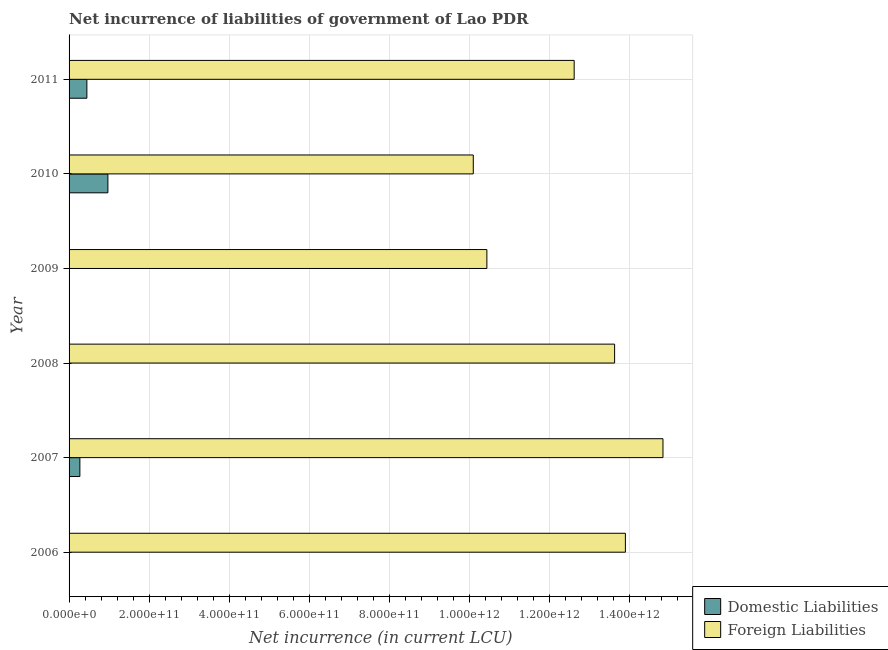How many different coloured bars are there?
Your answer should be very brief. 2. Are the number of bars on each tick of the Y-axis equal?
Provide a succinct answer. No. What is the label of the 2nd group of bars from the top?
Ensure brevity in your answer.  2010. In how many cases, is the number of bars for a given year not equal to the number of legend labels?
Make the answer very short. 3. What is the net incurrence of foreign liabilities in 2008?
Make the answer very short. 1.36e+12. Across all years, what is the maximum net incurrence of domestic liabilities?
Your answer should be compact. 9.70e+1. Across all years, what is the minimum net incurrence of foreign liabilities?
Provide a short and direct response. 1.01e+12. In which year was the net incurrence of domestic liabilities maximum?
Provide a short and direct response. 2010. What is the total net incurrence of foreign liabilities in the graph?
Offer a terse response. 7.55e+12. What is the difference between the net incurrence of foreign liabilities in 2008 and that in 2009?
Keep it short and to the point. 3.19e+11. What is the difference between the net incurrence of foreign liabilities in 2008 and the net incurrence of domestic liabilities in 2007?
Provide a succinct answer. 1.34e+12. What is the average net incurrence of domestic liabilities per year?
Make the answer very short. 2.81e+1. In the year 2011, what is the difference between the net incurrence of domestic liabilities and net incurrence of foreign liabilities?
Make the answer very short. -1.22e+12. What is the ratio of the net incurrence of foreign liabilities in 2006 to that in 2009?
Your answer should be compact. 1.33. Is the net incurrence of foreign liabilities in 2007 less than that in 2008?
Provide a short and direct response. No. What is the difference between the highest and the second highest net incurrence of domestic liabilities?
Keep it short and to the point. 5.25e+1. What is the difference between the highest and the lowest net incurrence of domestic liabilities?
Ensure brevity in your answer.  9.70e+1. Is the sum of the net incurrence of foreign liabilities in 2008 and 2009 greater than the maximum net incurrence of domestic liabilities across all years?
Offer a very short reply. Yes. How many bars are there?
Provide a succinct answer. 9. Are all the bars in the graph horizontal?
Offer a terse response. Yes. How many years are there in the graph?
Your answer should be compact. 6. What is the difference between two consecutive major ticks on the X-axis?
Your answer should be compact. 2.00e+11. Are the values on the major ticks of X-axis written in scientific E-notation?
Provide a succinct answer. Yes. Does the graph contain any zero values?
Make the answer very short. Yes. What is the title of the graph?
Offer a terse response. Net incurrence of liabilities of government of Lao PDR. Does "Fraud firms" appear as one of the legend labels in the graph?
Your response must be concise. No. What is the label or title of the X-axis?
Offer a terse response. Net incurrence (in current LCU). What is the Net incurrence (in current LCU) of Domestic Liabilities in 2006?
Make the answer very short. 0. What is the Net incurrence (in current LCU) in Foreign Liabilities in 2006?
Your answer should be very brief. 1.39e+12. What is the Net incurrence (in current LCU) in Domestic Liabilities in 2007?
Offer a terse response. 2.70e+1. What is the Net incurrence (in current LCU) of Foreign Liabilities in 2007?
Ensure brevity in your answer.  1.48e+12. What is the Net incurrence (in current LCU) in Domestic Liabilities in 2008?
Your answer should be compact. 0. What is the Net incurrence (in current LCU) of Foreign Liabilities in 2008?
Your response must be concise. 1.36e+12. What is the Net incurrence (in current LCU) in Foreign Liabilities in 2009?
Your response must be concise. 1.04e+12. What is the Net incurrence (in current LCU) in Domestic Liabilities in 2010?
Give a very brief answer. 9.70e+1. What is the Net incurrence (in current LCU) of Foreign Liabilities in 2010?
Provide a succinct answer. 1.01e+12. What is the Net incurrence (in current LCU) of Domestic Liabilities in 2011?
Your response must be concise. 4.45e+1. What is the Net incurrence (in current LCU) of Foreign Liabilities in 2011?
Ensure brevity in your answer.  1.26e+12. Across all years, what is the maximum Net incurrence (in current LCU) of Domestic Liabilities?
Ensure brevity in your answer.  9.70e+1. Across all years, what is the maximum Net incurrence (in current LCU) of Foreign Liabilities?
Offer a very short reply. 1.48e+12. Across all years, what is the minimum Net incurrence (in current LCU) in Foreign Liabilities?
Keep it short and to the point. 1.01e+12. What is the total Net incurrence (in current LCU) in Domestic Liabilities in the graph?
Offer a terse response. 1.69e+11. What is the total Net incurrence (in current LCU) in Foreign Liabilities in the graph?
Provide a short and direct response. 7.55e+12. What is the difference between the Net incurrence (in current LCU) of Foreign Liabilities in 2006 and that in 2007?
Give a very brief answer. -9.39e+1. What is the difference between the Net incurrence (in current LCU) in Foreign Liabilities in 2006 and that in 2008?
Ensure brevity in your answer.  2.70e+1. What is the difference between the Net incurrence (in current LCU) of Foreign Liabilities in 2006 and that in 2009?
Your response must be concise. 3.46e+11. What is the difference between the Net incurrence (in current LCU) in Foreign Liabilities in 2006 and that in 2010?
Your answer should be compact. 3.80e+11. What is the difference between the Net incurrence (in current LCU) of Foreign Liabilities in 2006 and that in 2011?
Your answer should be very brief. 1.28e+11. What is the difference between the Net incurrence (in current LCU) in Foreign Liabilities in 2007 and that in 2008?
Provide a succinct answer. 1.21e+11. What is the difference between the Net incurrence (in current LCU) in Foreign Liabilities in 2007 and that in 2009?
Give a very brief answer. 4.40e+11. What is the difference between the Net incurrence (in current LCU) of Domestic Liabilities in 2007 and that in 2010?
Provide a short and direct response. -7.00e+1. What is the difference between the Net incurrence (in current LCU) in Foreign Liabilities in 2007 and that in 2010?
Give a very brief answer. 4.74e+11. What is the difference between the Net incurrence (in current LCU) of Domestic Liabilities in 2007 and that in 2011?
Make the answer very short. -1.75e+1. What is the difference between the Net incurrence (in current LCU) of Foreign Liabilities in 2007 and that in 2011?
Your answer should be compact. 2.22e+11. What is the difference between the Net incurrence (in current LCU) of Foreign Liabilities in 2008 and that in 2009?
Your answer should be very brief. 3.19e+11. What is the difference between the Net incurrence (in current LCU) in Foreign Liabilities in 2008 and that in 2010?
Ensure brevity in your answer.  3.53e+11. What is the difference between the Net incurrence (in current LCU) of Foreign Liabilities in 2008 and that in 2011?
Offer a terse response. 1.01e+11. What is the difference between the Net incurrence (in current LCU) of Foreign Liabilities in 2009 and that in 2010?
Ensure brevity in your answer.  3.40e+1. What is the difference between the Net incurrence (in current LCU) of Foreign Liabilities in 2009 and that in 2011?
Provide a succinct answer. -2.18e+11. What is the difference between the Net incurrence (in current LCU) of Domestic Liabilities in 2010 and that in 2011?
Keep it short and to the point. 5.25e+1. What is the difference between the Net incurrence (in current LCU) in Foreign Liabilities in 2010 and that in 2011?
Offer a very short reply. -2.52e+11. What is the difference between the Net incurrence (in current LCU) of Domestic Liabilities in 2007 and the Net incurrence (in current LCU) of Foreign Liabilities in 2008?
Your answer should be very brief. -1.34e+12. What is the difference between the Net incurrence (in current LCU) in Domestic Liabilities in 2007 and the Net incurrence (in current LCU) in Foreign Liabilities in 2009?
Ensure brevity in your answer.  -1.02e+12. What is the difference between the Net incurrence (in current LCU) in Domestic Liabilities in 2007 and the Net incurrence (in current LCU) in Foreign Liabilities in 2010?
Ensure brevity in your answer.  -9.83e+11. What is the difference between the Net incurrence (in current LCU) in Domestic Liabilities in 2007 and the Net incurrence (in current LCU) in Foreign Liabilities in 2011?
Make the answer very short. -1.24e+12. What is the difference between the Net incurrence (in current LCU) of Domestic Liabilities in 2010 and the Net incurrence (in current LCU) of Foreign Liabilities in 2011?
Keep it short and to the point. -1.17e+12. What is the average Net incurrence (in current LCU) in Domestic Liabilities per year?
Provide a succinct answer. 2.81e+1. What is the average Net incurrence (in current LCU) in Foreign Liabilities per year?
Your answer should be very brief. 1.26e+12. In the year 2007, what is the difference between the Net incurrence (in current LCU) in Domestic Liabilities and Net incurrence (in current LCU) in Foreign Liabilities?
Offer a terse response. -1.46e+12. In the year 2010, what is the difference between the Net incurrence (in current LCU) of Domestic Liabilities and Net incurrence (in current LCU) of Foreign Liabilities?
Give a very brief answer. -9.13e+11. In the year 2011, what is the difference between the Net incurrence (in current LCU) of Domestic Liabilities and Net incurrence (in current LCU) of Foreign Liabilities?
Offer a very short reply. -1.22e+12. What is the ratio of the Net incurrence (in current LCU) in Foreign Liabilities in 2006 to that in 2007?
Offer a terse response. 0.94. What is the ratio of the Net incurrence (in current LCU) in Foreign Liabilities in 2006 to that in 2008?
Offer a very short reply. 1.02. What is the ratio of the Net incurrence (in current LCU) of Foreign Liabilities in 2006 to that in 2009?
Make the answer very short. 1.33. What is the ratio of the Net incurrence (in current LCU) in Foreign Liabilities in 2006 to that in 2010?
Your answer should be compact. 1.38. What is the ratio of the Net incurrence (in current LCU) in Foreign Liabilities in 2006 to that in 2011?
Your response must be concise. 1.1. What is the ratio of the Net incurrence (in current LCU) of Foreign Liabilities in 2007 to that in 2008?
Ensure brevity in your answer.  1.09. What is the ratio of the Net incurrence (in current LCU) of Foreign Liabilities in 2007 to that in 2009?
Provide a succinct answer. 1.42. What is the ratio of the Net incurrence (in current LCU) in Domestic Liabilities in 2007 to that in 2010?
Give a very brief answer. 0.28. What is the ratio of the Net incurrence (in current LCU) of Foreign Liabilities in 2007 to that in 2010?
Your answer should be compact. 1.47. What is the ratio of the Net incurrence (in current LCU) in Domestic Liabilities in 2007 to that in 2011?
Make the answer very short. 0.61. What is the ratio of the Net incurrence (in current LCU) in Foreign Liabilities in 2007 to that in 2011?
Your answer should be compact. 1.18. What is the ratio of the Net incurrence (in current LCU) of Foreign Liabilities in 2008 to that in 2009?
Offer a very short reply. 1.31. What is the ratio of the Net incurrence (in current LCU) of Foreign Liabilities in 2008 to that in 2010?
Provide a succinct answer. 1.35. What is the ratio of the Net incurrence (in current LCU) of Foreign Liabilities in 2008 to that in 2011?
Give a very brief answer. 1.08. What is the ratio of the Net incurrence (in current LCU) in Foreign Liabilities in 2009 to that in 2010?
Offer a very short reply. 1.03. What is the ratio of the Net incurrence (in current LCU) of Foreign Liabilities in 2009 to that in 2011?
Provide a short and direct response. 0.83. What is the ratio of the Net incurrence (in current LCU) in Domestic Liabilities in 2010 to that in 2011?
Offer a very short reply. 2.18. What is the ratio of the Net incurrence (in current LCU) in Foreign Liabilities in 2010 to that in 2011?
Your answer should be very brief. 0.8. What is the difference between the highest and the second highest Net incurrence (in current LCU) in Domestic Liabilities?
Your answer should be compact. 5.25e+1. What is the difference between the highest and the second highest Net incurrence (in current LCU) of Foreign Liabilities?
Give a very brief answer. 9.39e+1. What is the difference between the highest and the lowest Net incurrence (in current LCU) of Domestic Liabilities?
Your answer should be very brief. 9.70e+1. What is the difference between the highest and the lowest Net incurrence (in current LCU) of Foreign Liabilities?
Your response must be concise. 4.74e+11. 